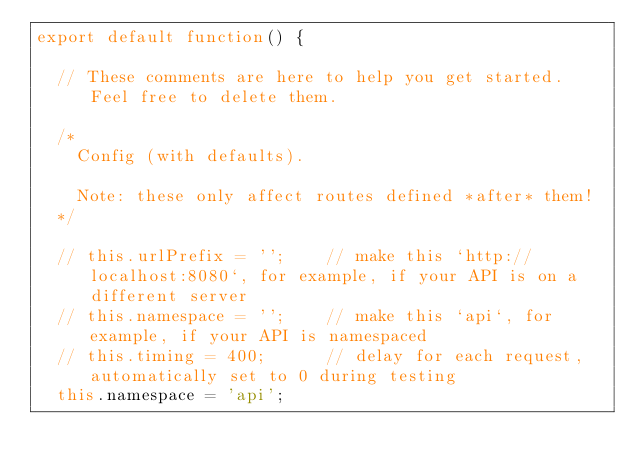Convert code to text. <code><loc_0><loc_0><loc_500><loc_500><_JavaScript_>export default function() {

  // These comments are here to help you get started. Feel free to delete them.

  /*
    Config (with defaults).

    Note: these only affect routes defined *after* them!
  */

  // this.urlPrefix = '';    // make this `http://localhost:8080`, for example, if your API is on a different server
  // this.namespace = '';    // make this `api`, for example, if your API is namespaced
  // this.timing = 400;      // delay for each request, automatically set to 0 during testing
  this.namespace = 'api';
</code> 